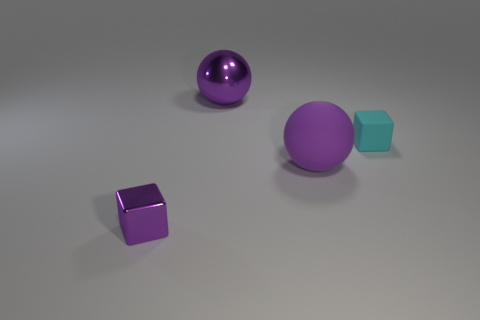Add 3 large green metal objects. How many objects exist? 7 Add 2 matte objects. How many matte objects exist? 4 Subtract 1 purple cubes. How many objects are left? 3 Subtract all large purple balls. Subtract all yellow metal spheres. How many objects are left? 2 Add 3 shiny blocks. How many shiny blocks are left? 4 